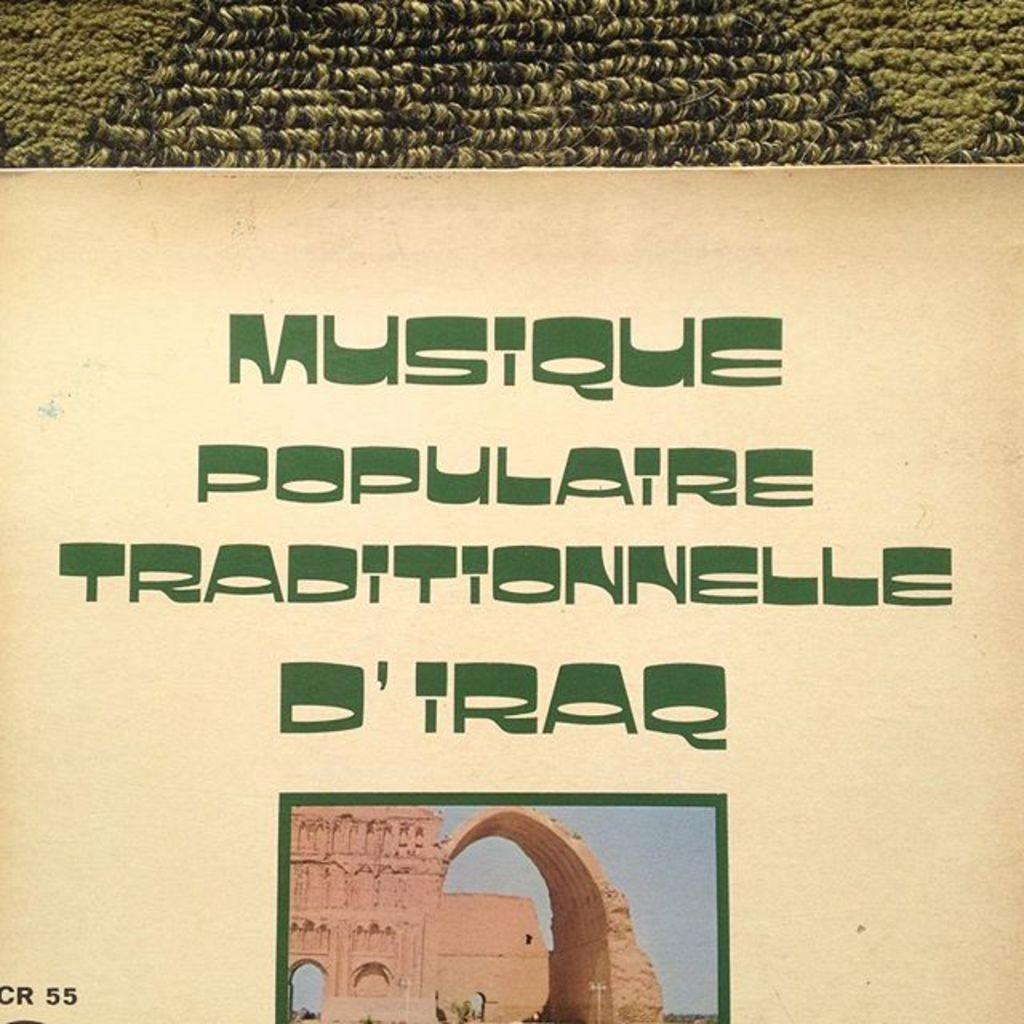What is the main object in the image? There is a board in the image. What else can be seen in the background of the image? There are buildings visible in the image. What is written on the board? There is writing on the board. What are the dominant colors in the background of the image? The background color of the image is green and black. Can you tell me how many hands the governor's son has in the image? There is no governor or son present in the image, and therefore no hands to count. 